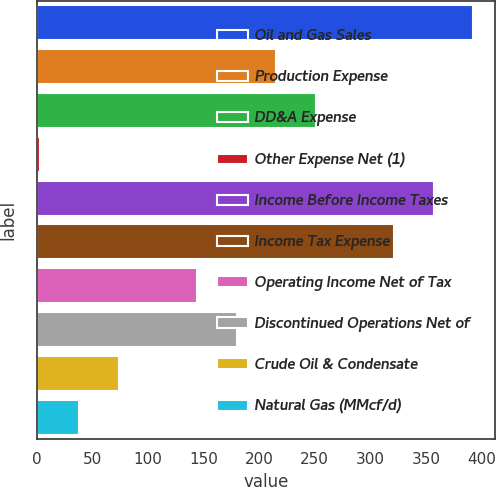Convert chart to OTSL. <chart><loc_0><loc_0><loc_500><loc_500><bar_chart><fcel>Oil and Gas Sales<fcel>Production Expense<fcel>DD&A Expense<fcel>Other Expense Net (1)<fcel>Income Before Income Taxes<fcel>Income Tax Expense<fcel>Operating Income Net of Tax<fcel>Discontinued Operations Net of<fcel>Crude Oil & Condensate<fcel>Natural Gas (MMcf/d)<nl><fcel>392.4<fcel>215.4<fcel>250.8<fcel>3<fcel>357<fcel>321.6<fcel>144.6<fcel>180<fcel>73.8<fcel>38.4<nl></chart> 